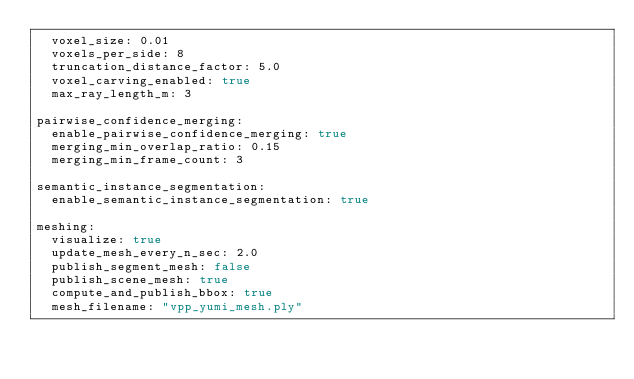<code> <loc_0><loc_0><loc_500><loc_500><_YAML_>  voxel_size: 0.01
  voxels_per_side: 8
  truncation_distance_factor: 5.0
  voxel_carving_enabled: true
  max_ray_length_m: 3

pairwise_confidence_merging:
  enable_pairwise_confidence_merging: true
  merging_min_overlap_ratio: 0.15
  merging_min_frame_count: 3

semantic_instance_segmentation:
  enable_semantic_instance_segmentation: true

meshing:
  visualize: true
  update_mesh_every_n_sec: 2.0
  publish_segment_mesh: false
  publish_scene_mesh: true
  compute_and_publish_bbox: true
  mesh_filename: "vpp_yumi_mesh.ply"
</code> 